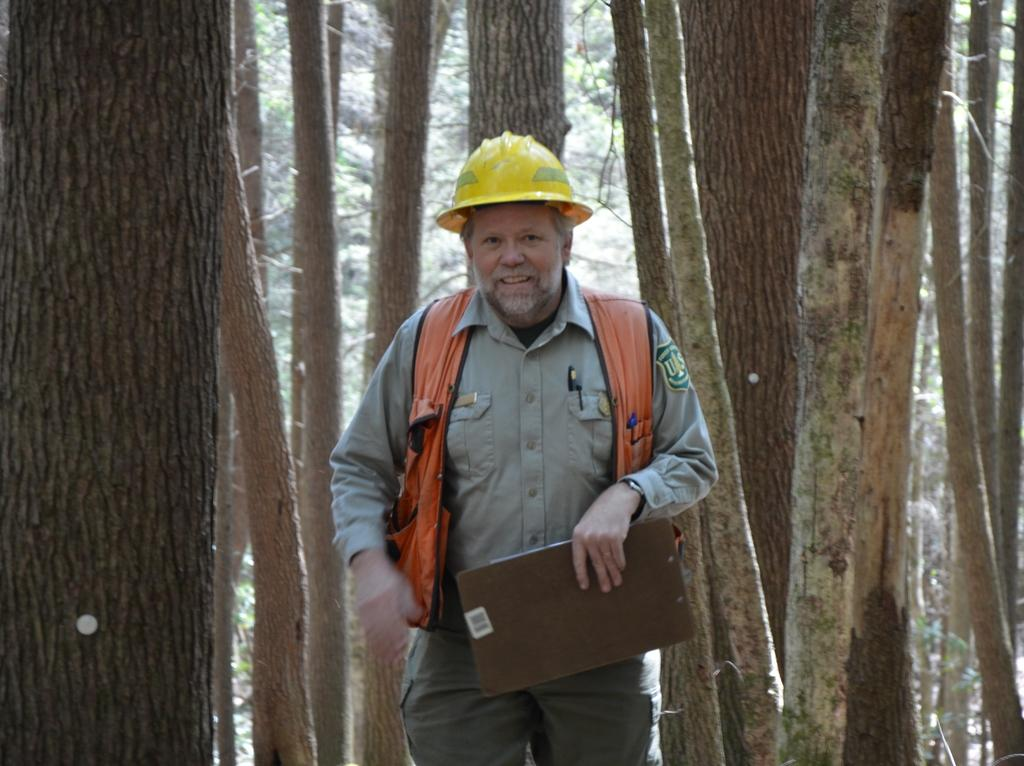What can be seen in the image? There is a person in the image. What is the person wearing? The person is wearing a dress and a helmet on their head. What is the person holding in their hand? The person is holding a pad in their hand. What is visible in the background of the image? There is a group of trees in the background of the image. What type of grass is growing around the maid in the image? There is no maid or grass present in the image. What mark can be seen on the person's forehead in the image? There is no mark visible on the person's forehead in the image. 